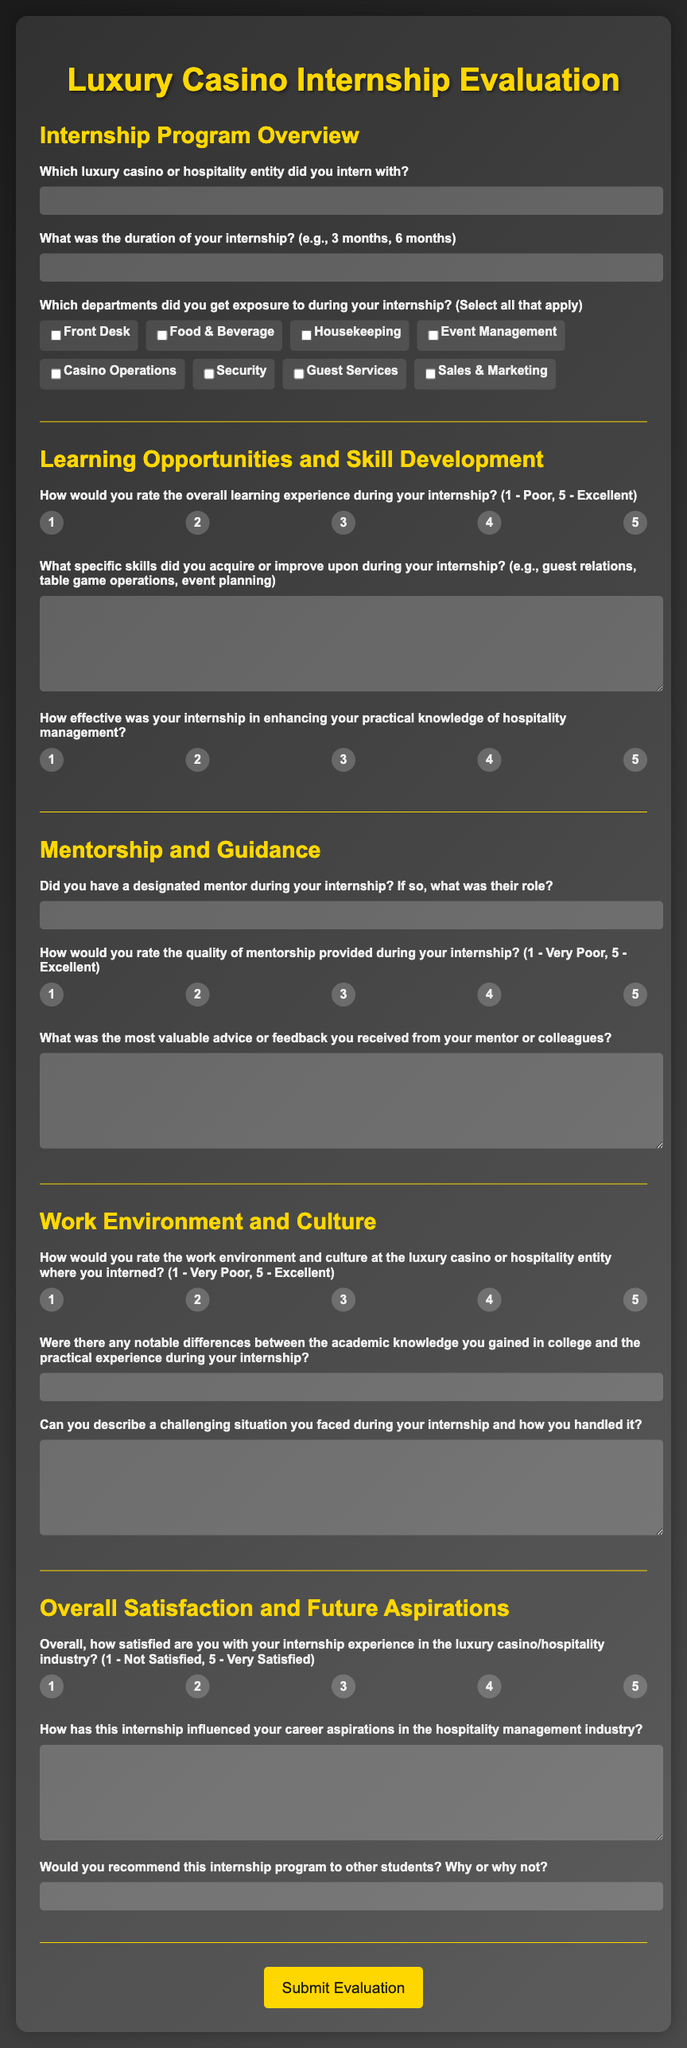What is the title of the survey form? The title of the survey form is specified in the header of the document, which clearly states its purpose.
Answer: Luxury Casino Internship Evaluation How many sections are in the survey? The document contains multiple sections that categorize the various parts of the evaluation survey for ease of understanding.
Answer: Five What rating scale is used for the overall learning experience question? The rating scale for the overall learning experience question ranges from a minimum to a maximum value, providing clear options for respondents to express their views.
Answer: 1 to 5 Which department is not listed for exposure during the internship? Understanding the list of departments helps identify options not included, illustrating the scope of internship areas covered.
Answer: None (No specific department is excluded) What is required in the 'What specific skills did you acquire or improve upon during your internship?' section? The responses to this section should focus on the personal development of skills gained through the internship experience, requiring detailed individual input.
Answer: Specific skills Would you recommend this internship program to other students? This question prompts respondents to reflect on their overall experience and provides insight into the program's effectiveness.
Answer: Yes/No (Depends on individual opinion) 